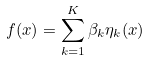<formula> <loc_0><loc_0><loc_500><loc_500>f ( x ) = \sum _ { k = 1 } ^ { K } \beta _ { k } \eta _ { k } ( x )</formula> 